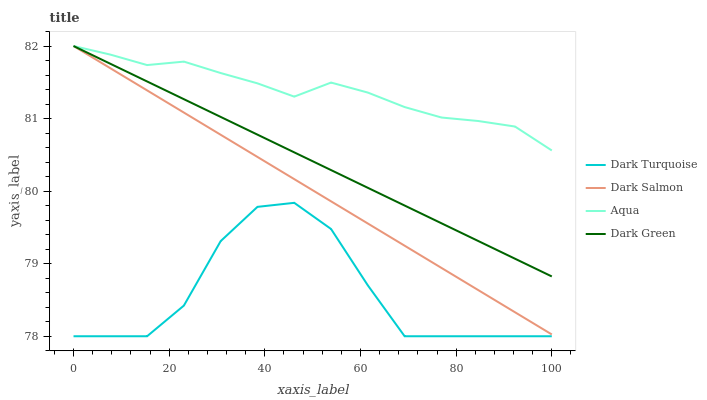Does Dark Turquoise have the minimum area under the curve?
Answer yes or no. Yes. Does Aqua have the maximum area under the curve?
Answer yes or no. Yes. Does Dark Salmon have the minimum area under the curve?
Answer yes or no. No. Does Dark Salmon have the maximum area under the curve?
Answer yes or no. No. Is Dark Green the smoothest?
Answer yes or no. Yes. Is Dark Turquoise the roughest?
Answer yes or no. Yes. Is Aqua the smoothest?
Answer yes or no. No. Is Aqua the roughest?
Answer yes or no. No. Does Dark Turquoise have the lowest value?
Answer yes or no. Yes. Does Dark Salmon have the lowest value?
Answer yes or no. No. Does Dark Green have the highest value?
Answer yes or no. Yes. Is Dark Turquoise less than Aqua?
Answer yes or no. Yes. Is Dark Salmon greater than Dark Turquoise?
Answer yes or no. Yes. Does Dark Salmon intersect Dark Green?
Answer yes or no. Yes. Is Dark Salmon less than Dark Green?
Answer yes or no. No. Is Dark Salmon greater than Dark Green?
Answer yes or no. No. Does Dark Turquoise intersect Aqua?
Answer yes or no. No. 